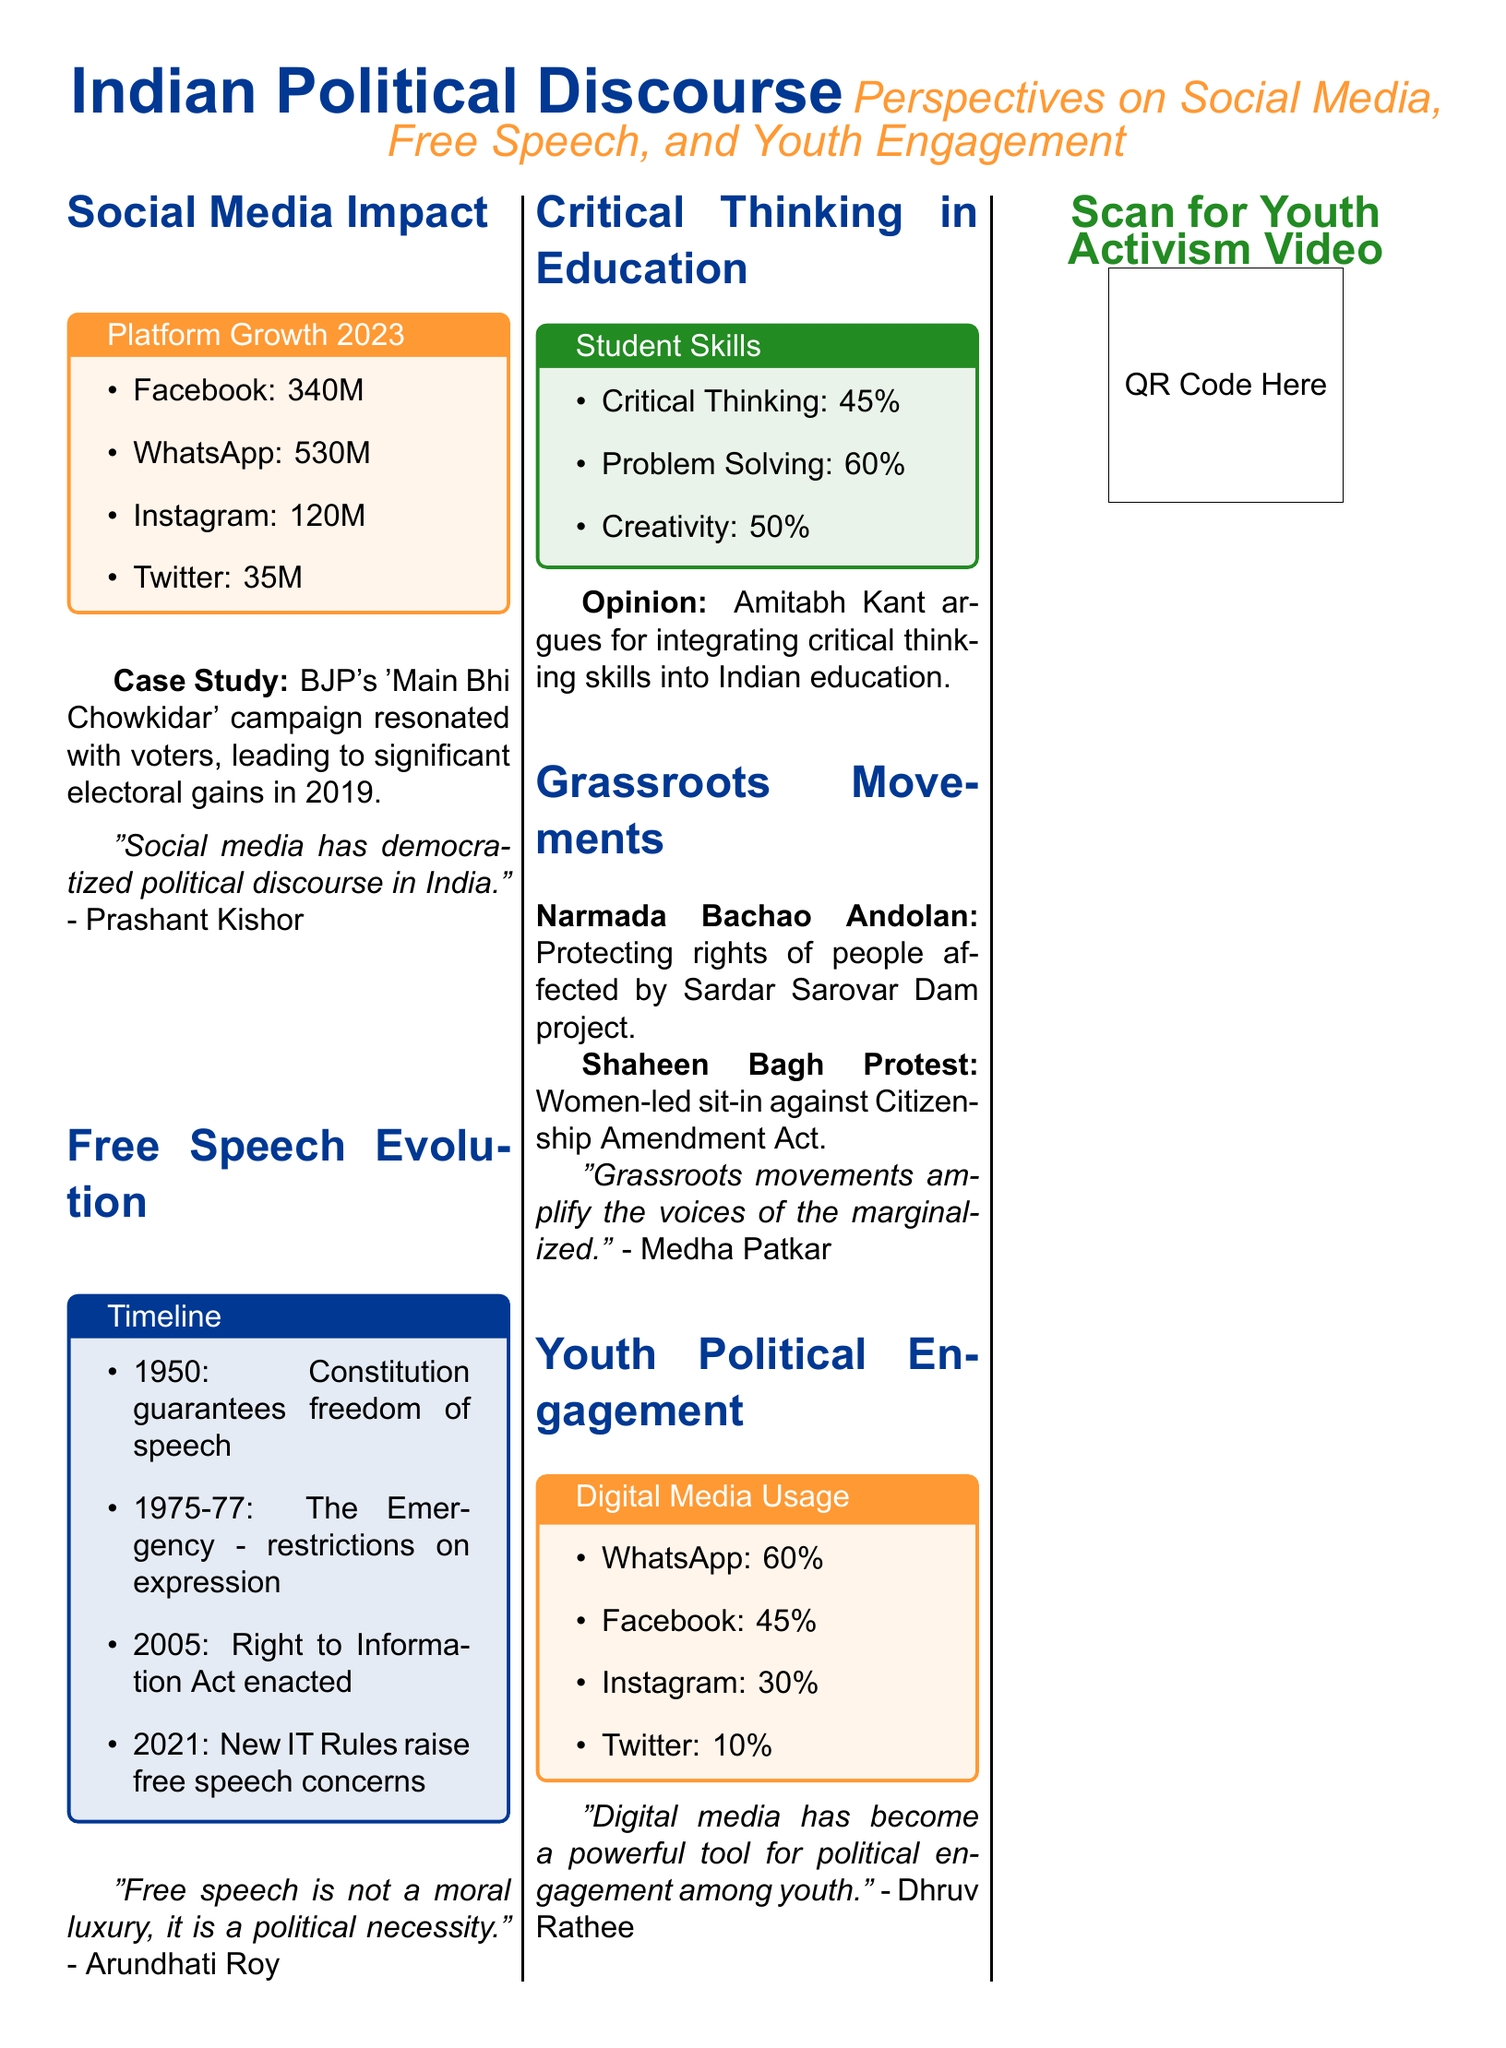What is the number of Facebook users in India? The number of Facebook users in the document is specifically stated as 340 million.
Answer: 340M What significant campaign did the BJP run in 2019? The document mentions the 'Main Bhi Chowkidar' campaign as significant for influencing voters.
Answer: 'Main Bhi Chowkidar' What year was the Right to Information Act enacted? The timeline specifically states that the Right to Information Act was enacted in 2005.
Answer: 2005 What percentage of students exhibit critical thinking skills? The document presents that 45% of students exhibit critical thinking skills.
Answer: 45% Which movement was focused on protecting rights related to the Sardar Sarovar Dam? The Narmada Bachao Andolan is identified in the document as focused on this issue.
Answer: Narmada Bachao Andolan What percentage of youth use WhatsApp for political engagement? The document states that 60% of youth use WhatsApp for political engagement.
Answer: 60% Who emphasized the integration of critical thinking in education? The document cites Amitabh Kant as arguing for this integration.
Answer: Amitabh Kant What is the title of the segment discussing youth political engagement? The segment is titled 'Youth Political Engagement' and highlights digital media usage.
Answer: Youth Political Engagement What color is used for the background of the case study on social media impact? The background color for the case study is saffron with a lighter tone.
Answer: saffron 